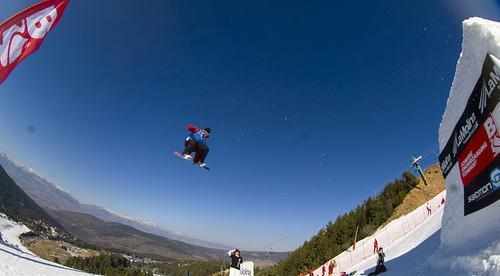How many bears are there?
Give a very brief answer. 0. 